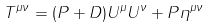Convert formula to latex. <formula><loc_0><loc_0><loc_500><loc_500>T ^ { \mu \nu } = ( P + D ) U ^ { \mu } U ^ { \nu } + P \eta ^ { \mu \nu }</formula> 